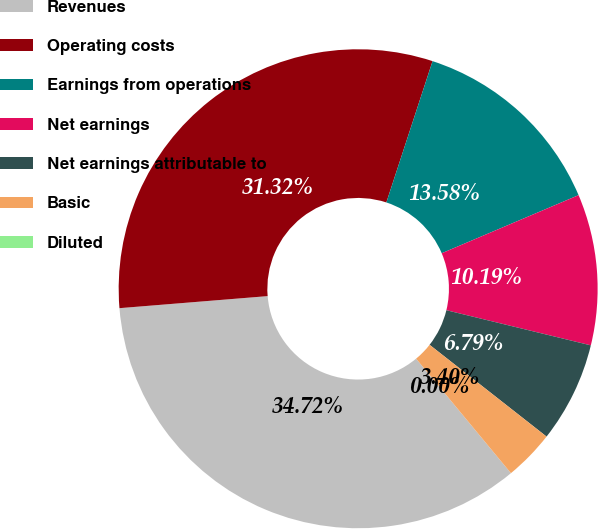Convert chart to OTSL. <chart><loc_0><loc_0><loc_500><loc_500><pie_chart><fcel>Revenues<fcel>Operating costs<fcel>Earnings from operations<fcel>Net earnings<fcel>Net earnings attributable to<fcel>Basic<fcel>Diluted<nl><fcel>34.72%<fcel>31.32%<fcel>13.58%<fcel>10.19%<fcel>6.79%<fcel>3.4%<fcel>0.0%<nl></chart> 